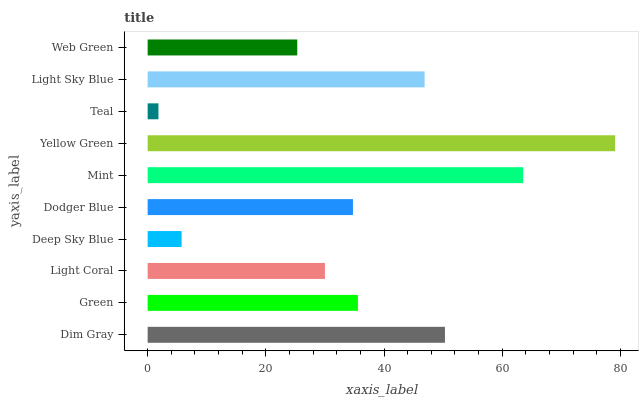Is Teal the minimum?
Answer yes or no. Yes. Is Yellow Green the maximum?
Answer yes or no. Yes. Is Green the minimum?
Answer yes or no. No. Is Green the maximum?
Answer yes or no. No. Is Dim Gray greater than Green?
Answer yes or no. Yes. Is Green less than Dim Gray?
Answer yes or no. Yes. Is Green greater than Dim Gray?
Answer yes or no. No. Is Dim Gray less than Green?
Answer yes or no. No. Is Green the high median?
Answer yes or no. Yes. Is Dodger Blue the low median?
Answer yes or no. Yes. Is Web Green the high median?
Answer yes or no. No. Is Teal the low median?
Answer yes or no. No. 